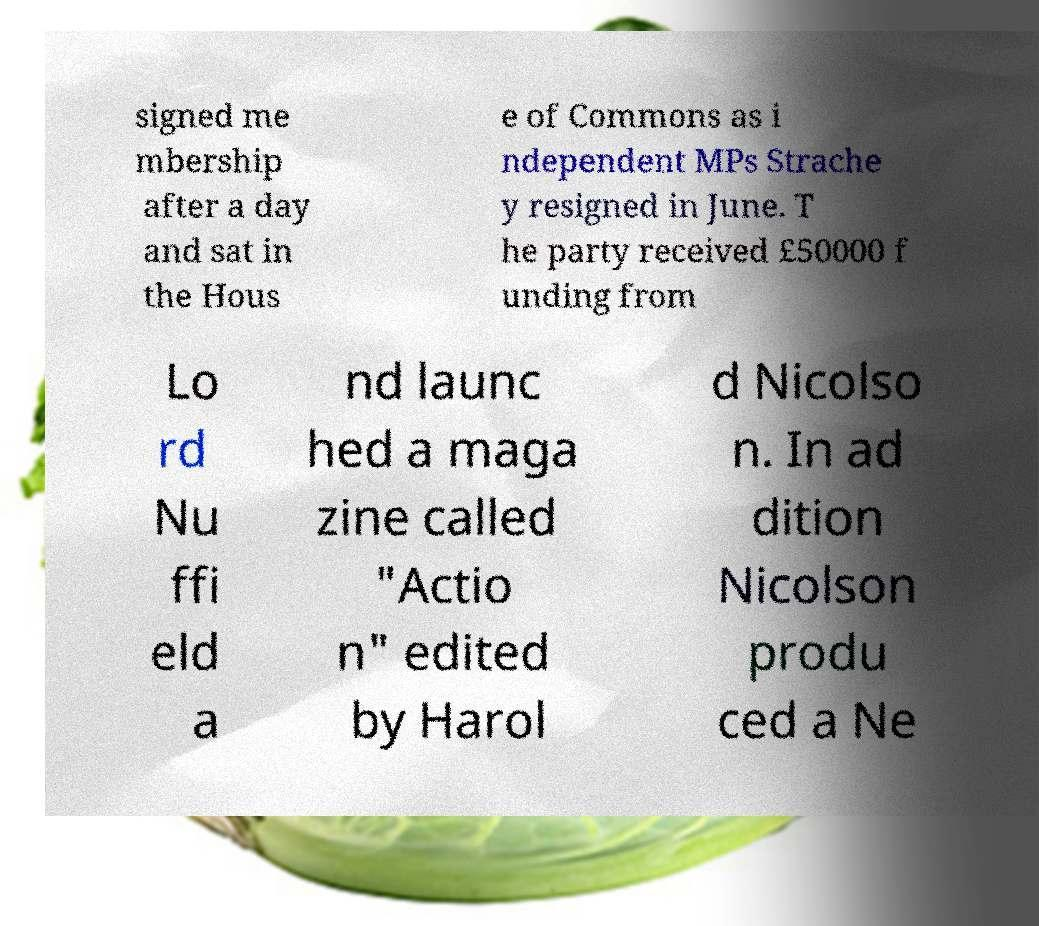Could you extract and type out the text from this image? signed me mbership after a day and sat in the Hous e of Commons as i ndependent MPs Strache y resigned in June. T he party received £50000 f unding from Lo rd Nu ffi eld a nd launc hed a maga zine called "Actio n" edited by Harol d Nicolso n. In ad dition Nicolson produ ced a Ne 